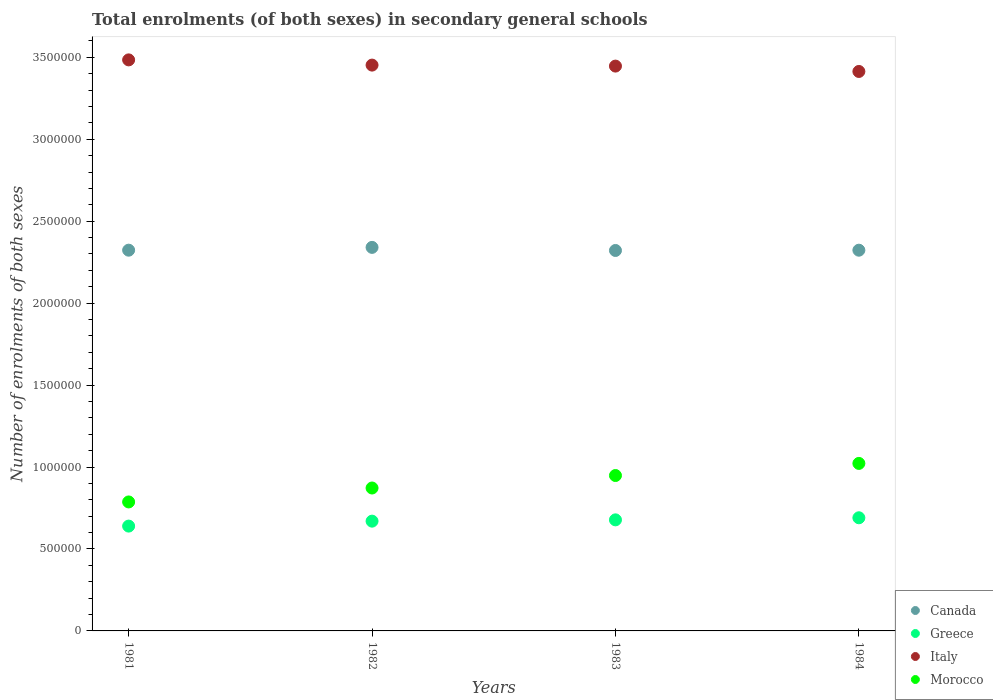Is the number of dotlines equal to the number of legend labels?
Ensure brevity in your answer.  Yes. What is the number of enrolments in secondary schools in Morocco in 1983?
Your answer should be compact. 9.48e+05. Across all years, what is the maximum number of enrolments in secondary schools in Canada?
Provide a short and direct response. 2.34e+06. Across all years, what is the minimum number of enrolments in secondary schools in Greece?
Give a very brief answer. 6.40e+05. In which year was the number of enrolments in secondary schools in Morocco minimum?
Keep it short and to the point. 1981. What is the total number of enrolments in secondary schools in Morocco in the graph?
Make the answer very short. 3.63e+06. What is the difference between the number of enrolments in secondary schools in Canada in 1982 and that in 1983?
Ensure brevity in your answer.  1.89e+04. What is the difference between the number of enrolments in secondary schools in Italy in 1983 and the number of enrolments in secondary schools in Morocco in 1981?
Make the answer very short. 2.66e+06. What is the average number of enrolments in secondary schools in Italy per year?
Give a very brief answer. 3.45e+06. In the year 1984, what is the difference between the number of enrolments in secondary schools in Italy and number of enrolments in secondary schools in Greece?
Give a very brief answer. 2.72e+06. What is the ratio of the number of enrolments in secondary schools in Morocco in 1983 to that in 1984?
Offer a very short reply. 0.93. What is the difference between the highest and the second highest number of enrolments in secondary schools in Italy?
Your response must be concise. 3.18e+04. What is the difference between the highest and the lowest number of enrolments in secondary schools in Canada?
Offer a terse response. 1.89e+04. In how many years, is the number of enrolments in secondary schools in Canada greater than the average number of enrolments in secondary schools in Canada taken over all years?
Your answer should be very brief. 1. Is the sum of the number of enrolments in secondary schools in Morocco in 1983 and 1984 greater than the maximum number of enrolments in secondary schools in Italy across all years?
Offer a terse response. No. Is it the case that in every year, the sum of the number of enrolments in secondary schools in Morocco and number of enrolments in secondary schools in Italy  is greater than the number of enrolments in secondary schools in Canada?
Make the answer very short. Yes. Does the number of enrolments in secondary schools in Greece monotonically increase over the years?
Give a very brief answer. Yes. How many dotlines are there?
Offer a terse response. 4. How many years are there in the graph?
Offer a terse response. 4. What is the difference between two consecutive major ticks on the Y-axis?
Give a very brief answer. 5.00e+05. Does the graph contain any zero values?
Provide a succinct answer. No. Does the graph contain grids?
Provide a short and direct response. No. What is the title of the graph?
Give a very brief answer. Total enrolments (of both sexes) in secondary general schools. What is the label or title of the Y-axis?
Make the answer very short. Number of enrolments of both sexes. What is the Number of enrolments of both sexes in Canada in 1981?
Give a very brief answer. 2.32e+06. What is the Number of enrolments of both sexes of Greece in 1981?
Provide a short and direct response. 6.40e+05. What is the Number of enrolments of both sexes in Italy in 1981?
Ensure brevity in your answer.  3.48e+06. What is the Number of enrolments of both sexes of Morocco in 1981?
Give a very brief answer. 7.87e+05. What is the Number of enrolments of both sexes of Canada in 1982?
Keep it short and to the point. 2.34e+06. What is the Number of enrolments of both sexes in Greece in 1982?
Make the answer very short. 6.70e+05. What is the Number of enrolments of both sexes in Italy in 1982?
Give a very brief answer. 3.45e+06. What is the Number of enrolments of both sexes in Morocco in 1982?
Your answer should be compact. 8.72e+05. What is the Number of enrolments of both sexes of Canada in 1983?
Provide a succinct answer. 2.32e+06. What is the Number of enrolments of both sexes of Greece in 1983?
Provide a short and direct response. 6.78e+05. What is the Number of enrolments of both sexes of Italy in 1983?
Ensure brevity in your answer.  3.45e+06. What is the Number of enrolments of both sexes in Morocco in 1983?
Keep it short and to the point. 9.48e+05. What is the Number of enrolments of both sexes of Canada in 1984?
Give a very brief answer. 2.32e+06. What is the Number of enrolments of both sexes in Greece in 1984?
Your answer should be compact. 6.90e+05. What is the Number of enrolments of both sexes of Italy in 1984?
Your answer should be very brief. 3.41e+06. What is the Number of enrolments of both sexes of Morocco in 1984?
Offer a terse response. 1.02e+06. Across all years, what is the maximum Number of enrolments of both sexes in Canada?
Your response must be concise. 2.34e+06. Across all years, what is the maximum Number of enrolments of both sexes in Greece?
Your response must be concise. 6.90e+05. Across all years, what is the maximum Number of enrolments of both sexes of Italy?
Your answer should be compact. 3.48e+06. Across all years, what is the maximum Number of enrolments of both sexes of Morocco?
Give a very brief answer. 1.02e+06. Across all years, what is the minimum Number of enrolments of both sexes in Canada?
Offer a terse response. 2.32e+06. Across all years, what is the minimum Number of enrolments of both sexes in Greece?
Ensure brevity in your answer.  6.40e+05. Across all years, what is the minimum Number of enrolments of both sexes in Italy?
Offer a terse response. 3.41e+06. Across all years, what is the minimum Number of enrolments of both sexes in Morocco?
Keep it short and to the point. 7.87e+05. What is the total Number of enrolments of both sexes in Canada in the graph?
Offer a terse response. 9.31e+06. What is the total Number of enrolments of both sexes of Greece in the graph?
Keep it short and to the point. 2.68e+06. What is the total Number of enrolments of both sexes of Italy in the graph?
Make the answer very short. 1.38e+07. What is the total Number of enrolments of both sexes in Morocco in the graph?
Offer a very short reply. 3.63e+06. What is the difference between the Number of enrolments of both sexes of Canada in 1981 and that in 1982?
Offer a very short reply. -1.70e+04. What is the difference between the Number of enrolments of both sexes in Greece in 1981 and that in 1982?
Your response must be concise. -3.02e+04. What is the difference between the Number of enrolments of both sexes of Italy in 1981 and that in 1982?
Your answer should be very brief. 3.18e+04. What is the difference between the Number of enrolments of both sexes of Morocco in 1981 and that in 1982?
Give a very brief answer. -8.50e+04. What is the difference between the Number of enrolments of both sexes in Canada in 1981 and that in 1983?
Ensure brevity in your answer.  1847. What is the difference between the Number of enrolments of both sexes in Greece in 1981 and that in 1983?
Make the answer very short. -3.81e+04. What is the difference between the Number of enrolments of both sexes in Italy in 1981 and that in 1983?
Provide a succinct answer. 3.79e+04. What is the difference between the Number of enrolments of both sexes of Morocco in 1981 and that in 1983?
Offer a very short reply. -1.61e+05. What is the difference between the Number of enrolments of both sexes in Canada in 1981 and that in 1984?
Offer a terse response. 123. What is the difference between the Number of enrolments of both sexes in Greece in 1981 and that in 1984?
Keep it short and to the point. -5.07e+04. What is the difference between the Number of enrolments of both sexes in Italy in 1981 and that in 1984?
Your answer should be very brief. 7.07e+04. What is the difference between the Number of enrolments of both sexes in Morocco in 1981 and that in 1984?
Your response must be concise. -2.35e+05. What is the difference between the Number of enrolments of both sexes of Canada in 1982 and that in 1983?
Your answer should be very brief. 1.89e+04. What is the difference between the Number of enrolments of both sexes in Greece in 1982 and that in 1983?
Make the answer very short. -7900. What is the difference between the Number of enrolments of both sexes in Italy in 1982 and that in 1983?
Provide a succinct answer. 6060. What is the difference between the Number of enrolments of both sexes in Morocco in 1982 and that in 1983?
Your answer should be very brief. -7.62e+04. What is the difference between the Number of enrolments of both sexes of Canada in 1982 and that in 1984?
Give a very brief answer. 1.72e+04. What is the difference between the Number of enrolments of both sexes of Greece in 1982 and that in 1984?
Offer a very short reply. -2.06e+04. What is the difference between the Number of enrolments of both sexes of Italy in 1982 and that in 1984?
Keep it short and to the point. 3.88e+04. What is the difference between the Number of enrolments of both sexes in Morocco in 1982 and that in 1984?
Offer a terse response. -1.50e+05. What is the difference between the Number of enrolments of both sexes in Canada in 1983 and that in 1984?
Keep it short and to the point. -1724. What is the difference between the Number of enrolments of both sexes in Greece in 1983 and that in 1984?
Provide a succinct answer. -1.27e+04. What is the difference between the Number of enrolments of both sexes of Italy in 1983 and that in 1984?
Offer a terse response. 3.28e+04. What is the difference between the Number of enrolments of both sexes of Morocco in 1983 and that in 1984?
Offer a terse response. -7.39e+04. What is the difference between the Number of enrolments of both sexes in Canada in 1981 and the Number of enrolments of both sexes in Greece in 1982?
Offer a terse response. 1.65e+06. What is the difference between the Number of enrolments of both sexes in Canada in 1981 and the Number of enrolments of both sexes in Italy in 1982?
Keep it short and to the point. -1.13e+06. What is the difference between the Number of enrolments of both sexes of Canada in 1981 and the Number of enrolments of both sexes of Morocco in 1982?
Your response must be concise. 1.45e+06. What is the difference between the Number of enrolments of both sexes of Greece in 1981 and the Number of enrolments of both sexes of Italy in 1982?
Ensure brevity in your answer.  -2.81e+06. What is the difference between the Number of enrolments of both sexes in Greece in 1981 and the Number of enrolments of both sexes in Morocco in 1982?
Your response must be concise. -2.32e+05. What is the difference between the Number of enrolments of both sexes in Italy in 1981 and the Number of enrolments of both sexes in Morocco in 1982?
Make the answer very short. 2.61e+06. What is the difference between the Number of enrolments of both sexes of Canada in 1981 and the Number of enrolments of both sexes of Greece in 1983?
Provide a short and direct response. 1.65e+06. What is the difference between the Number of enrolments of both sexes in Canada in 1981 and the Number of enrolments of both sexes in Italy in 1983?
Keep it short and to the point. -1.12e+06. What is the difference between the Number of enrolments of both sexes in Canada in 1981 and the Number of enrolments of both sexes in Morocco in 1983?
Provide a succinct answer. 1.37e+06. What is the difference between the Number of enrolments of both sexes in Greece in 1981 and the Number of enrolments of both sexes in Italy in 1983?
Ensure brevity in your answer.  -2.81e+06. What is the difference between the Number of enrolments of both sexes of Greece in 1981 and the Number of enrolments of both sexes of Morocco in 1983?
Give a very brief answer. -3.09e+05. What is the difference between the Number of enrolments of both sexes in Italy in 1981 and the Number of enrolments of both sexes in Morocco in 1983?
Offer a terse response. 2.54e+06. What is the difference between the Number of enrolments of both sexes of Canada in 1981 and the Number of enrolments of both sexes of Greece in 1984?
Your answer should be compact. 1.63e+06. What is the difference between the Number of enrolments of both sexes in Canada in 1981 and the Number of enrolments of both sexes in Italy in 1984?
Your response must be concise. -1.09e+06. What is the difference between the Number of enrolments of both sexes of Canada in 1981 and the Number of enrolments of both sexes of Morocco in 1984?
Offer a terse response. 1.30e+06. What is the difference between the Number of enrolments of both sexes in Greece in 1981 and the Number of enrolments of both sexes in Italy in 1984?
Make the answer very short. -2.77e+06. What is the difference between the Number of enrolments of both sexes in Greece in 1981 and the Number of enrolments of both sexes in Morocco in 1984?
Your answer should be very brief. -3.82e+05. What is the difference between the Number of enrolments of both sexes in Italy in 1981 and the Number of enrolments of both sexes in Morocco in 1984?
Offer a very short reply. 2.46e+06. What is the difference between the Number of enrolments of both sexes of Canada in 1982 and the Number of enrolments of both sexes of Greece in 1983?
Offer a very short reply. 1.66e+06. What is the difference between the Number of enrolments of both sexes in Canada in 1982 and the Number of enrolments of both sexes in Italy in 1983?
Make the answer very short. -1.11e+06. What is the difference between the Number of enrolments of both sexes in Canada in 1982 and the Number of enrolments of both sexes in Morocco in 1983?
Your answer should be very brief. 1.39e+06. What is the difference between the Number of enrolments of both sexes in Greece in 1982 and the Number of enrolments of both sexes in Italy in 1983?
Ensure brevity in your answer.  -2.78e+06. What is the difference between the Number of enrolments of both sexes in Greece in 1982 and the Number of enrolments of both sexes in Morocco in 1983?
Your answer should be compact. -2.78e+05. What is the difference between the Number of enrolments of both sexes in Italy in 1982 and the Number of enrolments of both sexes in Morocco in 1983?
Ensure brevity in your answer.  2.50e+06. What is the difference between the Number of enrolments of both sexes of Canada in 1982 and the Number of enrolments of both sexes of Greece in 1984?
Provide a succinct answer. 1.65e+06. What is the difference between the Number of enrolments of both sexes in Canada in 1982 and the Number of enrolments of both sexes in Italy in 1984?
Offer a very short reply. -1.07e+06. What is the difference between the Number of enrolments of both sexes in Canada in 1982 and the Number of enrolments of both sexes in Morocco in 1984?
Keep it short and to the point. 1.32e+06. What is the difference between the Number of enrolments of both sexes in Greece in 1982 and the Number of enrolments of both sexes in Italy in 1984?
Your response must be concise. -2.74e+06. What is the difference between the Number of enrolments of both sexes of Greece in 1982 and the Number of enrolments of both sexes of Morocco in 1984?
Your answer should be compact. -3.52e+05. What is the difference between the Number of enrolments of both sexes of Italy in 1982 and the Number of enrolments of both sexes of Morocco in 1984?
Ensure brevity in your answer.  2.43e+06. What is the difference between the Number of enrolments of both sexes in Canada in 1983 and the Number of enrolments of both sexes in Greece in 1984?
Offer a very short reply. 1.63e+06. What is the difference between the Number of enrolments of both sexes in Canada in 1983 and the Number of enrolments of both sexes in Italy in 1984?
Provide a succinct answer. -1.09e+06. What is the difference between the Number of enrolments of both sexes in Canada in 1983 and the Number of enrolments of both sexes in Morocco in 1984?
Keep it short and to the point. 1.30e+06. What is the difference between the Number of enrolments of both sexes of Greece in 1983 and the Number of enrolments of both sexes of Italy in 1984?
Make the answer very short. -2.74e+06. What is the difference between the Number of enrolments of both sexes of Greece in 1983 and the Number of enrolments of both sexes of Morocco in 1984?
Your response must be concise. -3.44e+05. What is the difference between the Number of enrolments of both sexes in Italy in 1983 and the Number of enrolments of both sexes in Morocco in 1984?
Offer a very short reply. 2.42e+06. What is the average Number of enrolments of both sexes in Canada per year?
Provide a short and direct response. 2.33e+06. What is the average Number of enrolments of both sexes in Greece per year?
Offer a terse response. 6.69e+05. What is the average Number of enrolments of both sexes of Italy per year?
Keep it short and to the point. 3.45e+06. What is the average Number of enrolments of both sexes of Morocco per year?
Provide a succinct answer. 9.07e+05. In the year 1981, what is the difference between the Number of enrolments of both sexes in Canada and Number of enrolments of both sexes in Greece?
Offer a terse response. 1.68e+06. In the year 1981, what is the difference between the Number of enrolments of both sexes in Canada and Number of enrolments of both sexes in Italy?
Provide a short and direct response. -1.16e+06. In the year 1981, what is the difference between the Number of enrolments of both sexes of Canada and Number of enrolments of both sexes of Morocco?
Offer a very short reply. 1.54e+06. In the year 1981, what is the difference between the Number of enrolments of both sexes of Greece and Number of enrolments of both sexes of Italy?
Offer a terse response. -2.84e+06. In the year 1981, what is the difference between the Number of enrolments of both sexes in Greece and Number of enrolments of both sexes in Morocco?
Your answer should be very brief. -1.47e+05. In the year 1981, what is the difference between the Number of enrolments of both sexes in Italy and Number of enrolments of both sexes in Morocco?
Make the answer very short. 2.70e+06. In the year 1982, what is the difference between the Number of enrolments of both sexes in Canada and Number of enrolments of both sexes in Greece?
Ensure brevity in your answer.  1.67e+06. In the year 1982, what is the difference between the Number of enrolments of both sexes of Canada and Number of enrolments of both sexes of Italy?
Your answer should be compact. -1.11e+06. In the year 1982, what is the difference between the Number of enrolments of both sexes in Canada and Number of enrolments of both sexes in Morocco?
Make the answer very short. 1.47e+06. In the year 1982, what is the difference between the Number of enrolments of both sexes in Greece and Number of enrolments of both sexes in Italy?
Your response must be concise. -2.78e+06. In the year 1982, what is the difference between the Number of enrolments of both sexes of Greece and Number of enrolments of both sexes of Morocco?
Make the answer very short. -2.02e+05. In the year 1982, what is the difference between the Number of enrolments of both sexes in Italy and Number of enrolments of both sexes in Morocco?
Make the answer very short. 2.58e+06. In the year 1983, what is the difference between the Number of enrolments of both sexes of Canada and Number of enrolments of both sexes of Greece?
Make the answer very short. 1.64e+06. In the year 1983, what is the difference between the Number of enrolments of both sexes in Canada and Number of enrolments of both sexes in Italy?
Your answer should be very brief. -1.13e+06. In the year 1983, what is the difference between the Number of enrolments of both sexes of Canada and Number of enrolments of both sexes of Morocco?
Make the answer very short. 1.37e+06. In the year 1983, what is the difference between the Number of enrolments of both sexes in Greece and Number of enrolments of both sexes in Italy?
Provide a succinct answer. -2.77e+06. In the year 1983, what is the difference between the Number of enrolments of both sexes of Greece and Number of enrolments of both sexes of Morocco?
Make the answer very short. -2.71e+05. In the year 1983, what is the difference between the Number of enrolments of both sexes of Italy and Number of enrolments of both sexes of Morocco?
Provide a short and direct response. 2.50e+06. In the year 1984, what is the difference between the Number of enrolments of both sexes in Canada and Number of enrolments of both sexes in Greece?
Keep it short and to the point. 1.63e+06. In the year 1984, what is the difference between the Number of enrolments of both sexes of Canada and Number of enrolments of both sexes of Italy?
Provide a short and direct response. -1.09e+06. In the year 1984, what is the difference between the Number of enrolments of both sexes in Canada and Number of enrolments of both sexes in Morocco?
Offer a very short reply. 1.30e+06. In the year 1984, what is the difference between the Number of enrolments of both sexes of Greece and Number of enrolments of both sexes of Italy?
Ensure brevity in your answer.  -2.72e+06. In the year 1984, what is the difference between the Number of enrolments of both sexes of Greece and Number of enrolments of both sexes of Morocco?
Your answer should be compact. -3.32e+05. In the year 1984, what is the difference between the Number of enrolments of both sexes in Italy and Number of enrolments of both sexes in Morocco?
Ensure brevity in your answer.  2.39e+06. What is the ratio of the Number of enrolments of both sexes in Greece in 1981 to that in 1982?
Keep it short and to the point. 0.95. What is the ratio of the Number of enrolments of both sexes of Italy in 1981 to that in 1982?
Give a very brief answer. 1.01. What is the ratio of the Number of enrolments of both sexes in Morocco in 1981 to that in 1982?
Your answer should be compact. 0.9. What is the ratio of the Number of enrolments of both sexes in Greece in 1981 to that in 1983?
Offer a terse response. 0.94. What is the ratio of the Number of enrolments of both sexes of Morocco in 1981 to that in 1983?
Give a very brief answer. 0.83. What is the ratio of the Number of enrolments of both sexes of Greece in 1981 to that in 1984?
Make the answer very short. 0.93. What is the ratio of the Number of enrolments of both sexes of Italy in 1981 to that in 1984?
Offer a terse response. 1.02. What is the ratio of the Number of enrolments of both sexes in Morocco in 1981 to that in 1984?
Offer a terse response. 0.77. What is the ratio of the Number of enrolments of both sexes of Greece in 1982 to that in 1983?
Your answer should be very brief. 0.99. What is the ratio of the Number of enrolments of both sexes in Italy in 1982 to that in 1983?
Offer a very short reply. 1. What is the ratio of the Number of enrolments of both sexes of Morocco in 1982 to that in 1983?
Your answer should be compact. 0.92. What is the ratio of the Number of enrolments of both sexes in Canada in 1982 to that in 1984?
Provide a succinct answer. 1.01. What is the ratio of the Number of enrolments of both sexes of Greece in 1982 to that in 1984?
Your answer should be very brief. 0.97. What is the ratio of the Number of enrolments of both sexes in Italy in 1982 to that in 1984?
Make the answer very short. 1.01. What is the ratio of the Number of enrolments of both sexes of Morocco in 1982 to that in 1984?
Provide a short and direct response. 0.85. What is the ratio of the Number of enrolments of both sexes in Canada in 1983 to that in 1984?
Keep it short and to the point. 1. What is the ratio of the Number of enrolments of both sexes in Greece in 1983 to that in 1984?
Your response must be concise. 0.98. What is the ratio of the Number of enrolments of both sexes in Italy in 1983 to that in 1984?
Provide a short and direct response. 1.01. What is the ratio of the Number of enrolments of both sexes of Morocco in 1983 to that in 1984?
Offer a very short reply. 0.93. What is the difference between the highest and the second highest Number of enrolments of both sexes in Canada?
Make the answer very short. 1.70e+04. What is the difference between the highest and the second highest Number of enrolments of both sexes in Greece?
Offer a terse response. 1.27e+04. What is the difference between the highest and the second highest Number of enrolments of both sexes of Italy?
Provide a succinct answer. 3.18e+04. What is the difference between the highest and the second highest Number of enrolments of both sexes of Morocco?
Keep it short and to the point. 7.39e+04. What is the difference between the highest and the lowest Number of enrolments of both sexes in Canada?
Provide a short and direct response. 1.89e+04. What is the difference between the highest and the lowest Number of enrolments of both sexes in Greece?
Give a very brief answer. 5.07e+04. What is the difference between the highest and the lowest Number of enrolments of both sexes in Italy?
Provide a short and direct response. 7.07e+04. What is the difference between the highest and the lowest Number of enrolments of both sexes in Morocco?
Give a very brief answer. 2.35e+05. 